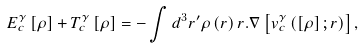<formula> <loc_0><loc_0><loc_500><loc_500>E _ { c } ^ { \gamma } \left [ \rho \right ] + T _ { c } ^ { \gamma } \left [ \rho \right ] = - \int d ^ { 3 } r ^ { \prime } \rho \left ( r \right ) r . \nabla \left [ v _ { c } ^ { \gamma } \left ( \left [ \rho \right ] ; r \right ) \right ] ,</formula> 